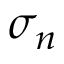<formula> <loc_0><loc_0><loc_500><loc_500>\sigma _ { n }</formula> 